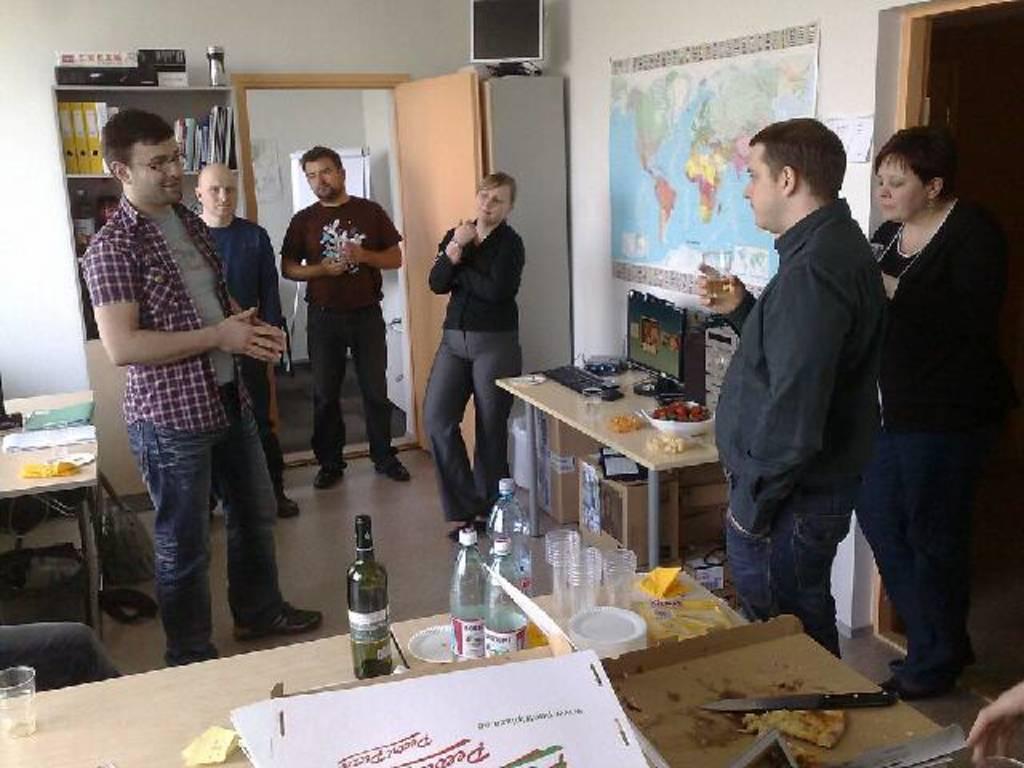Please provide a concise description of this image. In this image there are group of people standing near table , there is monitor, keyboard glass, mouse, bowl, food, a map attached to a wall, speaker , door , books in rack , table , bottle , glass, plate , knife , pizza, box , chair. 